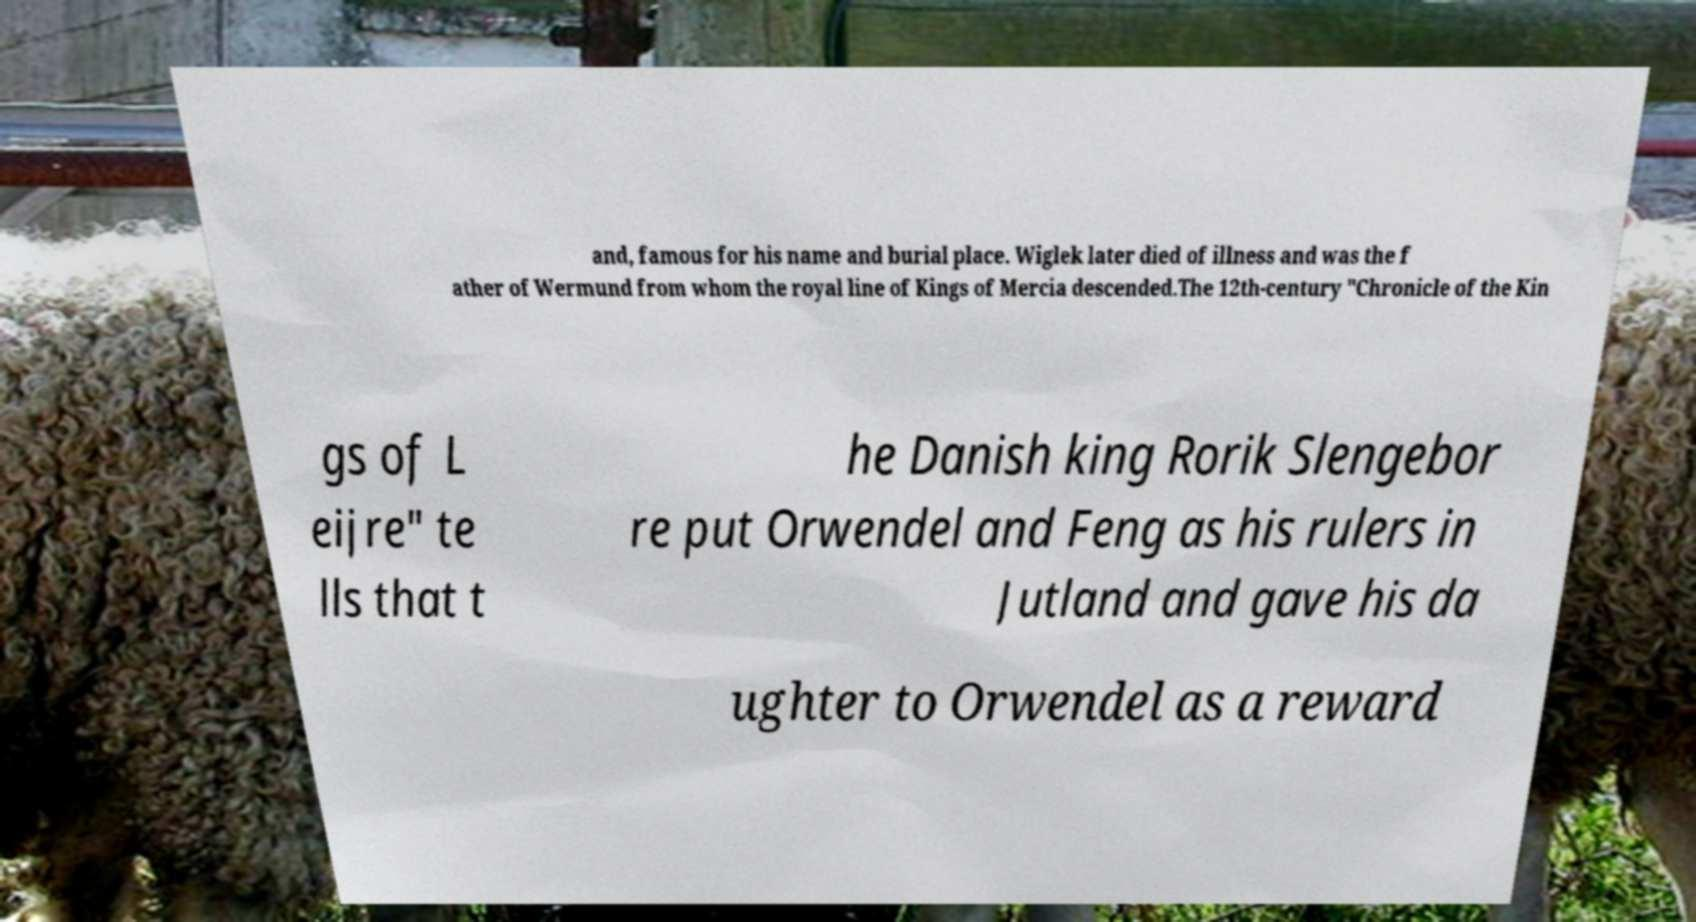I need the written content from this picture converted into text. Can you do that? and, famous for his name and burial place. Wiglek later died of illness and was the f ather of Wermund from whom the royal line of Kings of Mercia descended.The 12th-century "Chronicle of the Kin gs of L eijre" te lls that t he Danish king Rorik Slengebor re put Orwendel and Feng as his rulers in Jutland and gave his da ughter to Orwendel as a reward 